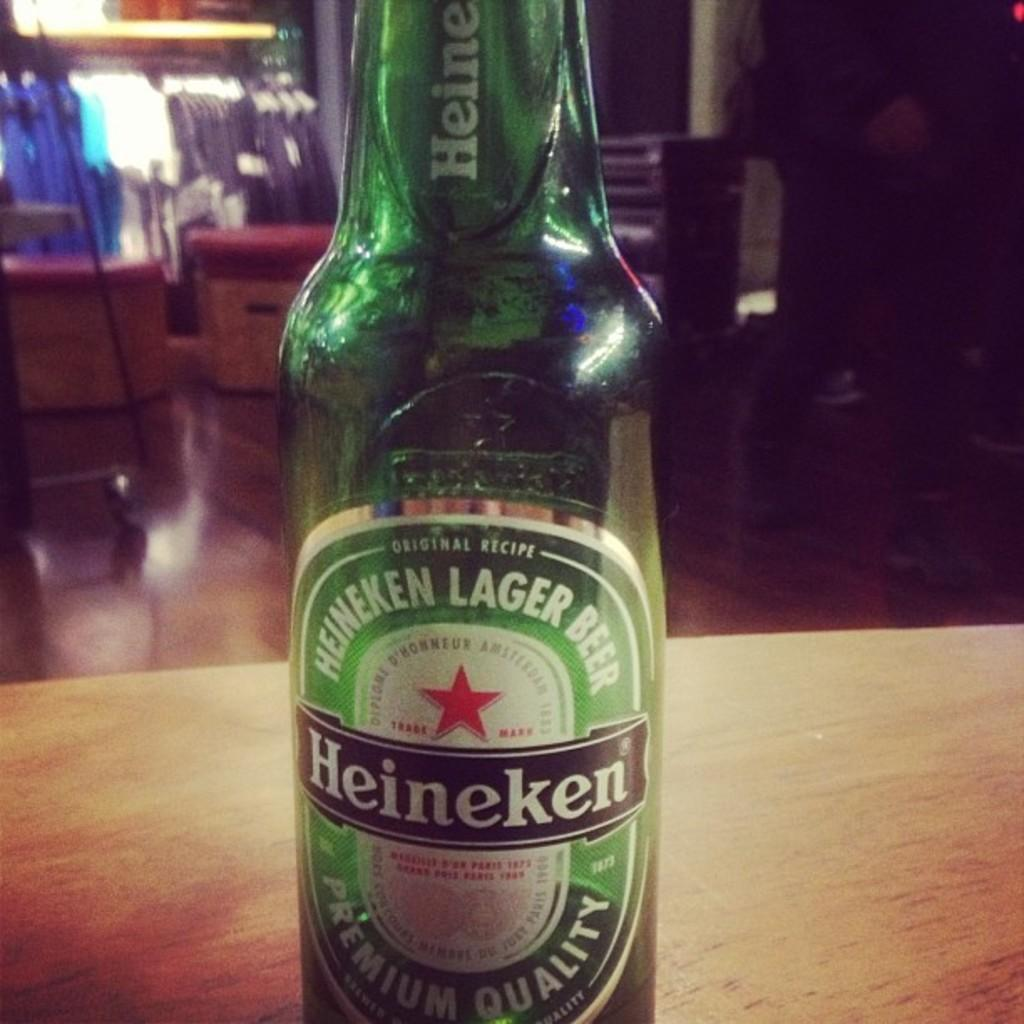<image>
Give a short and clear explanation of the subsequent image. A green bottle of Heineken is on a wooden table. 